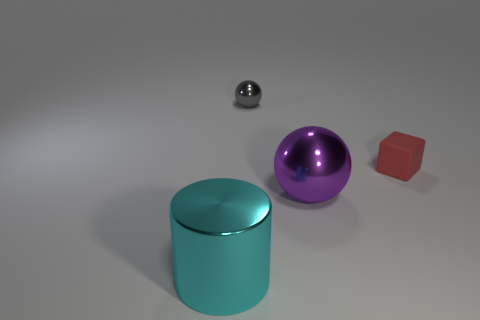What number of things are shiny things or tiny cyan shiny spheres?
Your answer should be very brief. 3. How many other objects are there of the same shape as the small shiny thing?
Offer a very short reply. 1. Does the big object that is right of the gray shiny ball have the same material as the small object on the left side of the large purple ball?
Make the answer very short. Yes. What shape is the thing that is in front of the tiny cube and to the right of the cyan object?
Make the answer very short. Sphere. Are there any other things that have the same material as the red block?
Keep it short and to the point. No. There is a object that is behind the purple sphere and in front of the small metal sphere; what material is it?
Give a very brief answer. Rubber. What shape is the cyan thing that is the same material as the gray ball?
Your answer should be compact. Cylinder. Are there more balls that are behind the small matte cube than big blue metal cylinders?
Your response must be concise. Yes. What material is the cyan object?
Provide a succinct answer. Metal. What number of metallic objects have the same size as the rubber object?
Provide a succinct answer. 1. 